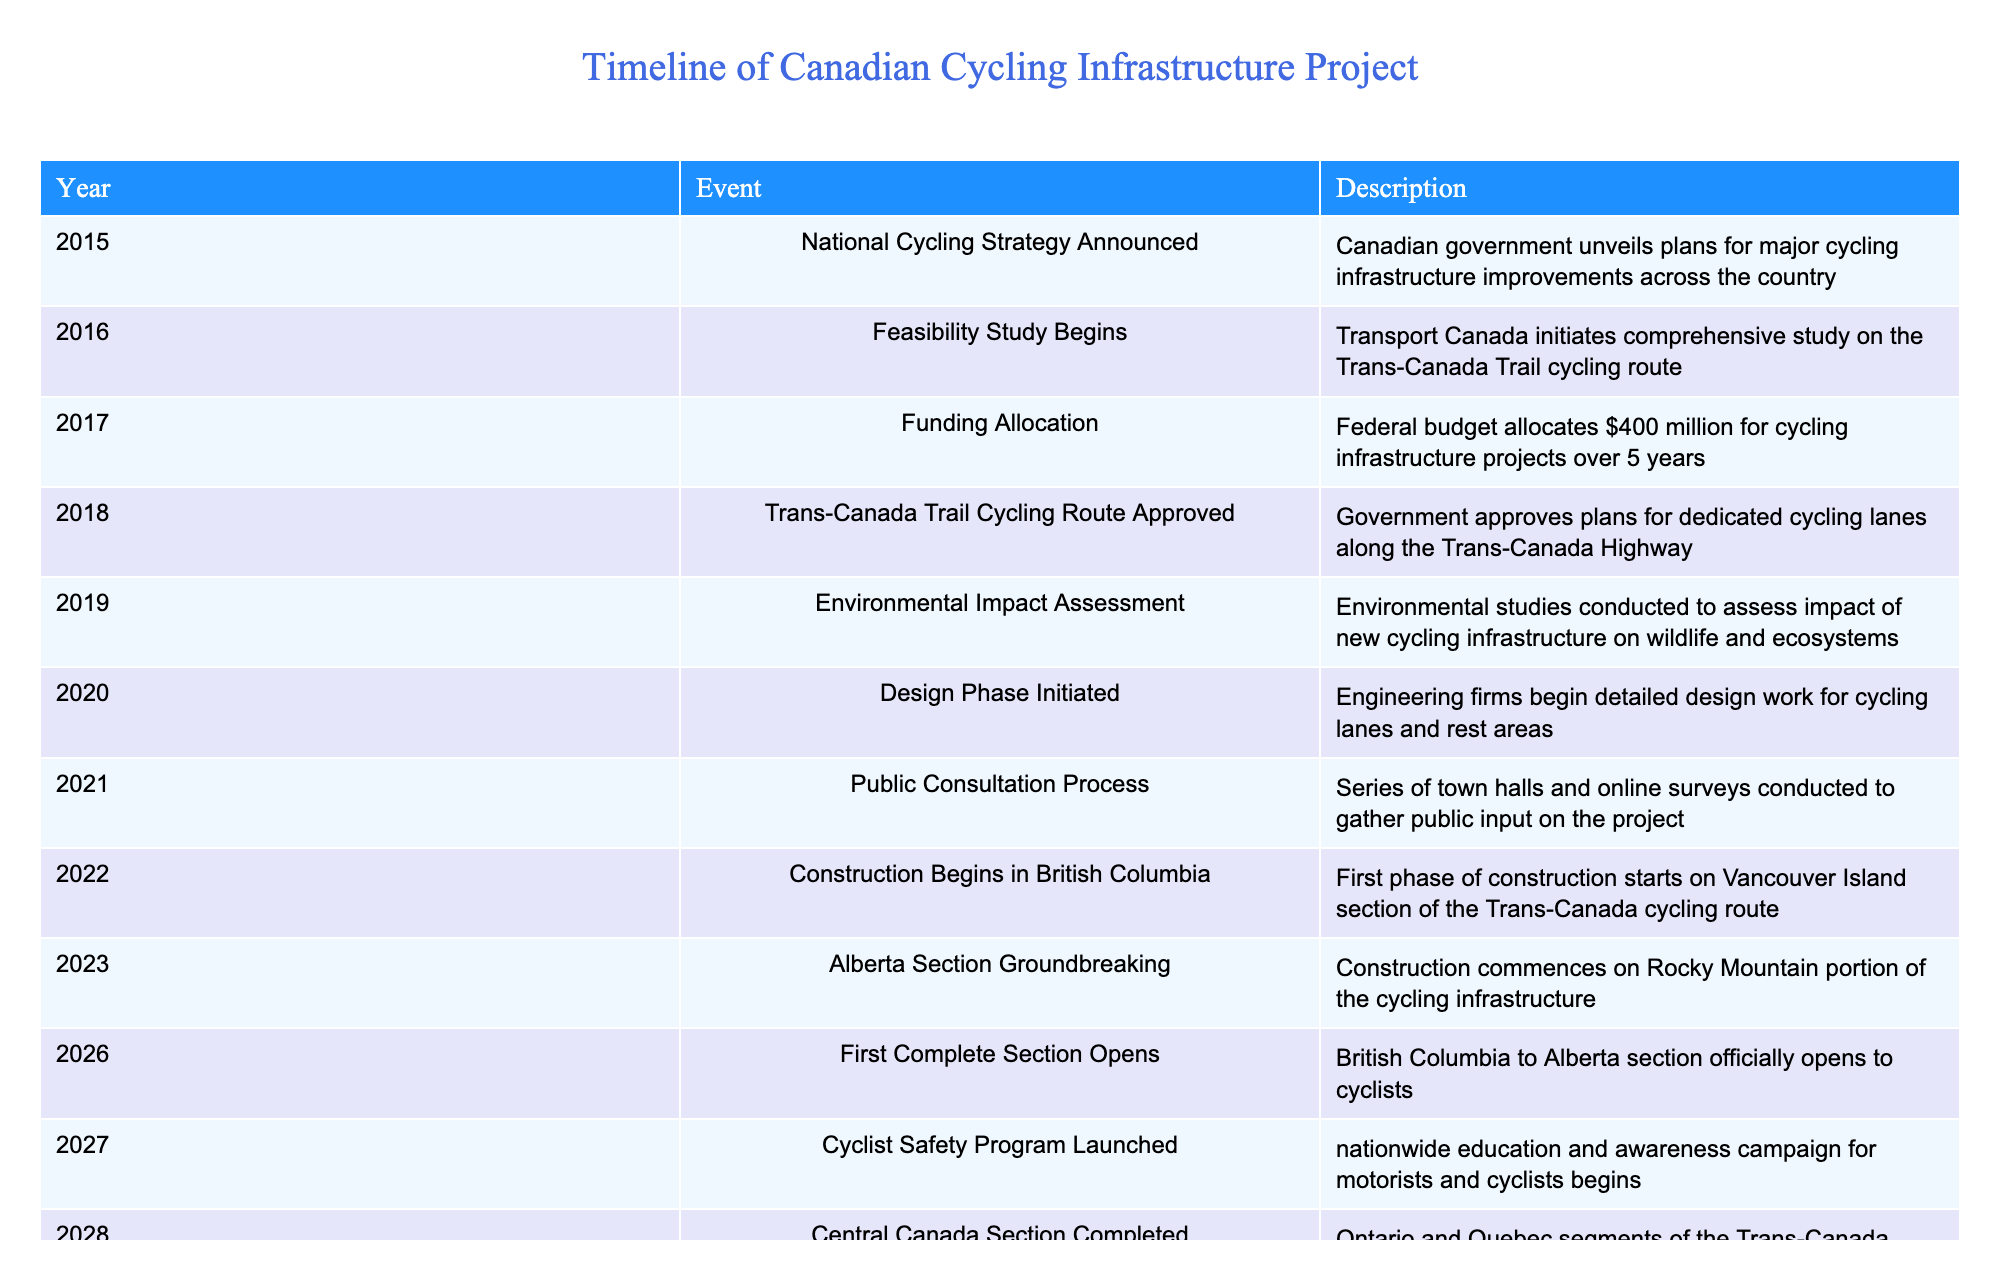What year was the National Cycling Strategy announced? The table shows that the National Cycling Strategy was announced in 2015 under the "Event" column.
Answer: 2015 How much funding was allocated for cycling infrastructure projects in 2017? According to the table, the federal budget allocated $400 million in 2017 specifically for cycling infrastructure projects, as stated in the "Description" column.
Answer: $400 million Was an environmental impact assessment conducted for the cycling project? The table indicates that an Environmental Impact Assessment occurred in 2019, confirming that the assessment was indeed conducted.
Answer: Yes In which year did construction begin in British Columbia? The table reveals that construction began in British Columbia in 2022, as listed in the "Year" column.
Answer: 2022 What is the time span between the announcement of the National Cycling Strategy and the opening of the first complete section? The first complete section opened in 2026 and the National Cycling Strategy was announced in 2015. Therefore, the time span is 2026 - 2015 = 11 years.
Answer: 11 years How many years passed between the approval of the Trans-Canada Trail Cycling Route and the completion of the Central Canada Section? The Trans-Canada Trail Cycling Route was approved in 2018 and the Central Canada Section was completed in 2028, so the difference is 2028 - 2018 = 10 years.
Answer: 10 years Did the construction on the Atlantic Canada Section complete before the launch of the Cyclist Safety Program? The table indicates the Atlantic Canada Section was finished in 2029 and the Cyclist Safety Program was launched in 2027, so construction was completed after the program was launched.
Answer: No What was the first major event to officially open the entire Trans-Canada Cycling Route? According to the table, the full Trans-Canada Cycling Route was officially inaugurated with a cross-country relay event in 2030 as that year’s listed.
Answer: Cross-country relay event How many sections of the Trans-Canada Cycling Route were completed by the end of 2029? The table shows that by 2029, the Atlantic Canada Section was the last to finish. Therefore, completed sections are: British Columbia to Alberta and Central Canada, making it a total of 3 completed sections by the end of 2029 since it includes the already completed one prior.
Answer: 3 sections 